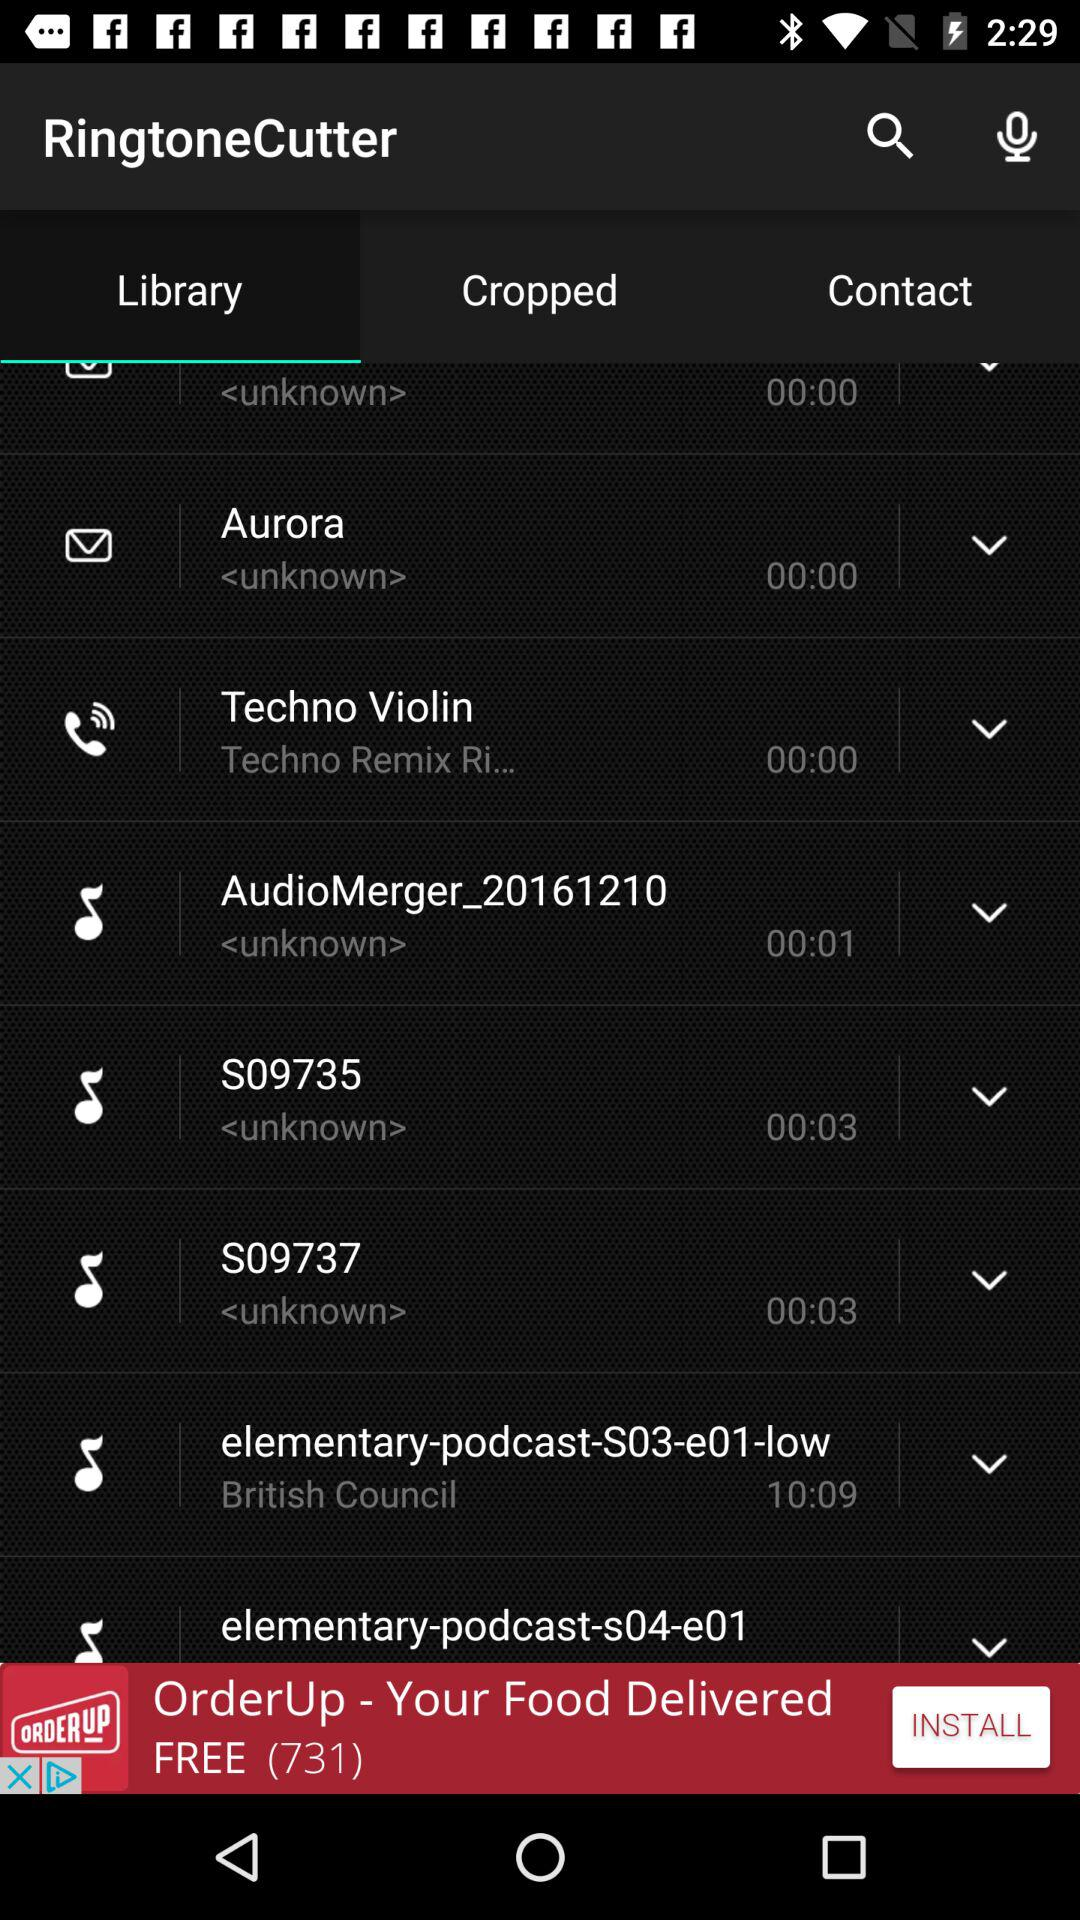What is the duration of the ringtone "elementary-podcast-S03-e01-low"? The duration is 10 minutes 9 seconds. 